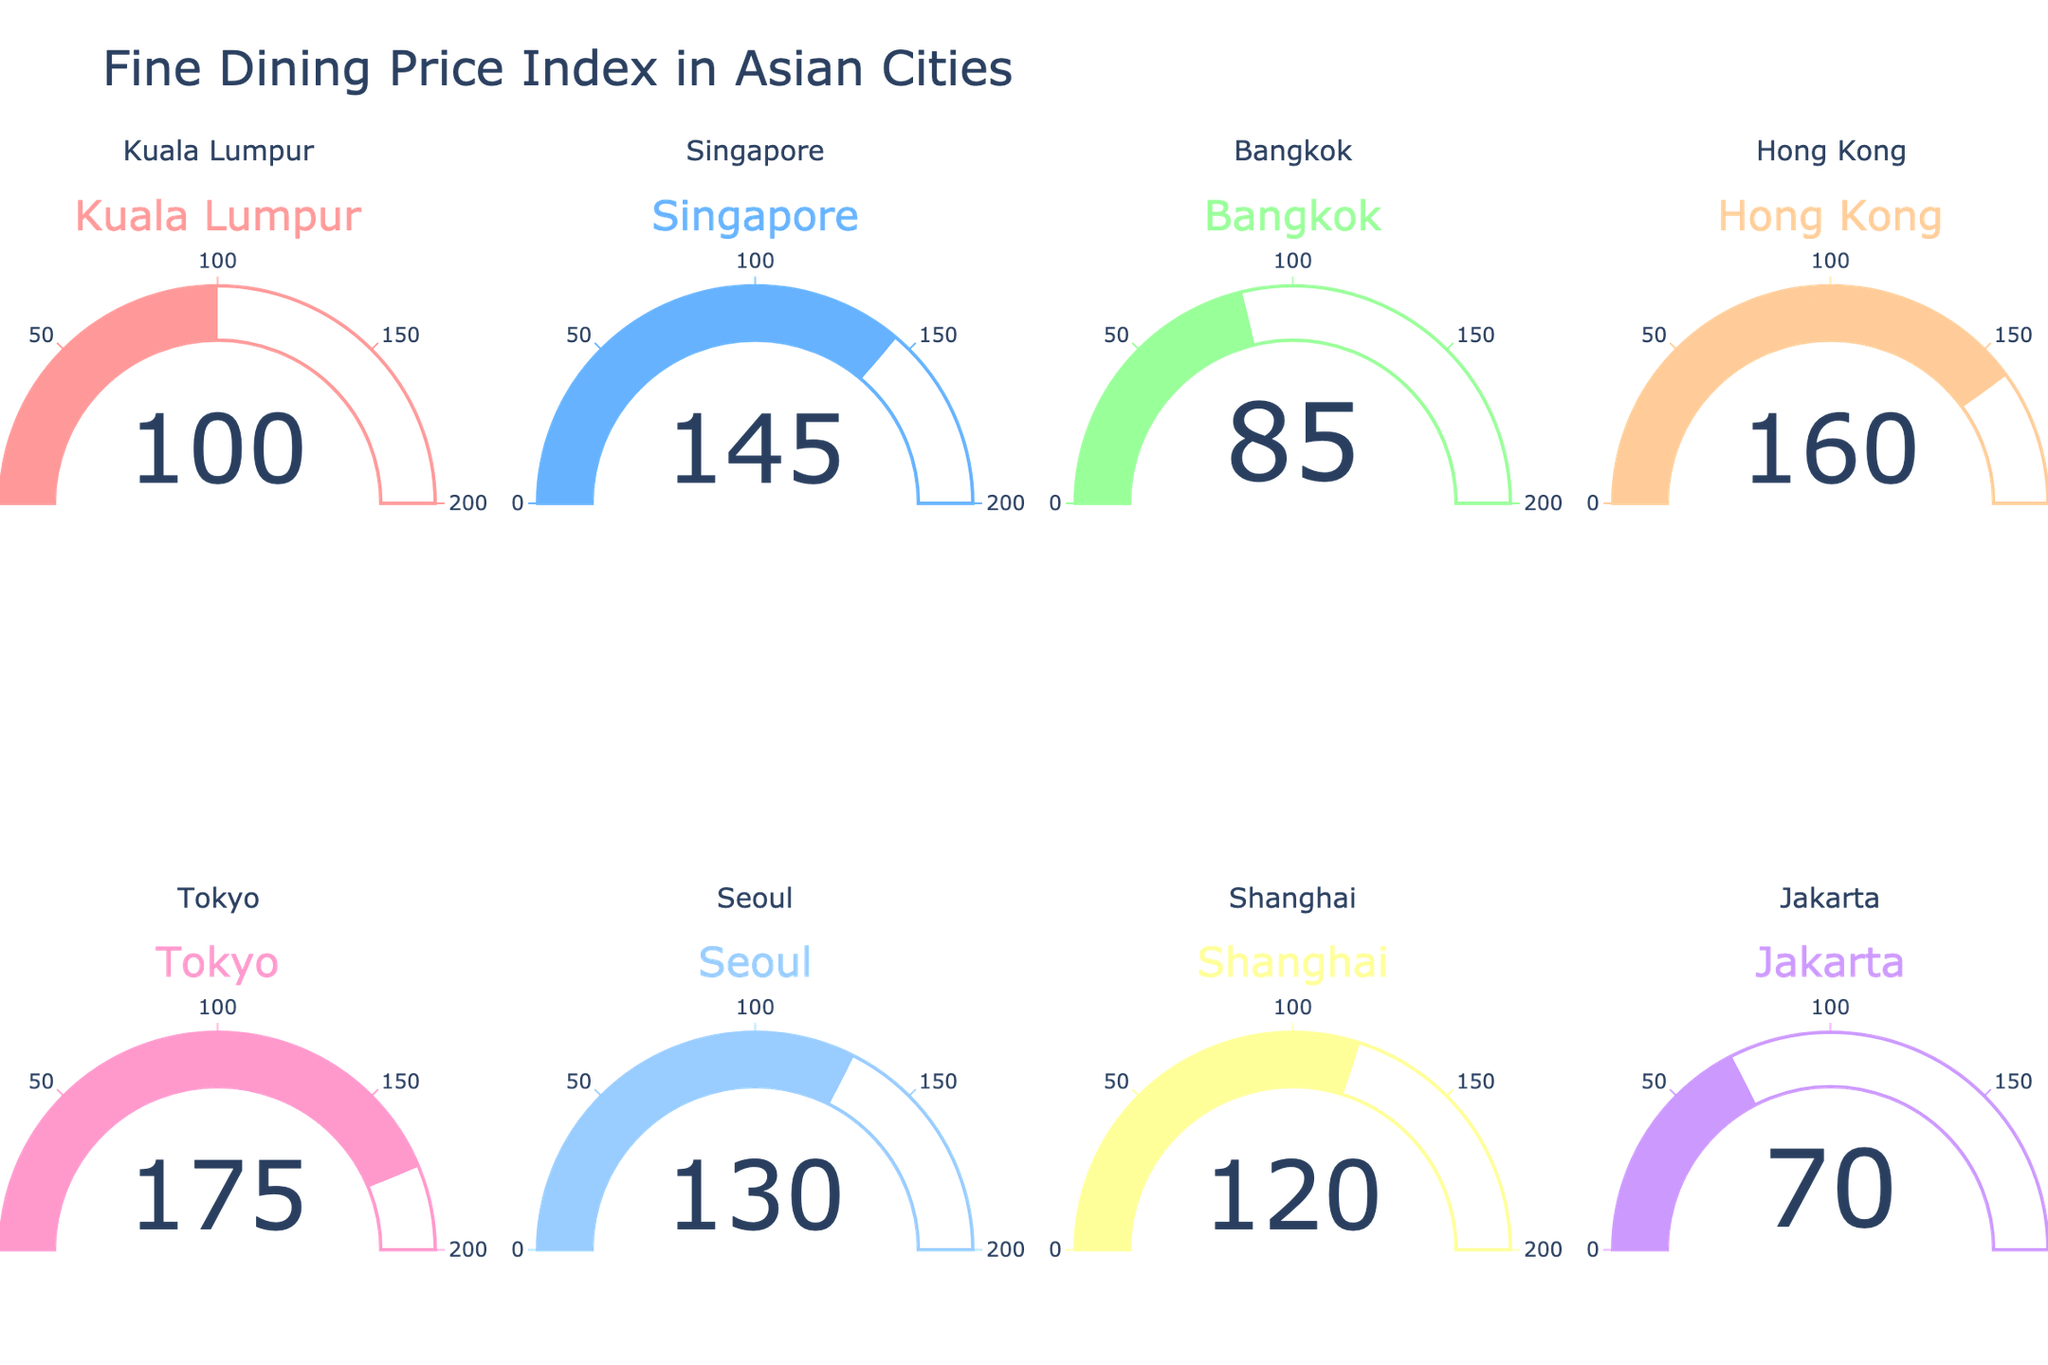What's the price index for Tokyo? The gauge chart indicates the price index for each city separately. For Tokyo, the gauge shows a value of 175.
Answer: 175 Which city has the highest price index? By examining each gauge, the highest numerical value is seen in Tokyo with a price index of 175.
Answer: Tokyo How does Kuala Lumpur's price index compare to Bangkok's? Kuala Lumpur has a price index of 100, and Bangkok has a price index of 85. Therefore, Kuala Lumpur's price index is higher than Bangkok's by 15 points.
Answer: Kuala Lumpur's is higher by 15 points What's the median price index of all the cities? Listing the price indices in ascending order: 70 (Jakarta), 85 (Bangkok), 100 (Kuala Lumpur), 120 (Shanghai), 130 (Seoul), 145 (Singapore), 160 (Hong Kong), 175 (Tokyo). The middle values (4th and 5th) are 120 and 130, so the median is (120 + 130) / 2 = 125.
Answer: 125 Which cities have a price index greater than 150? From the gauge chart, cities with a price index greater than 150 are Hong Kong (160) and Tokyo (175).
Answer: Hong Kong and Tokyo What's the price index difference between the city with the highest value and the city with the lowest value? The highest price index is 175 (Tokyo), and the lowest is 70 (Jakarta). The difference is 175 - 70 = 105.
Answer: 105 What is the average price index of all the cities shown? Sum of all price indices: 100 + 145 + 85 + 160 + 175 + 130 + 120 + 70 = 985. Number of cities is 8, so the average is 985 / 8 = 123.125.
Answer: 123.125 Looking at the color scheme, what color represents Kuala Lumpur, and how does it compare visually to the others? Kuala Lumpur is represented by a red shade, while other cities are shown in shades of blue, green, yellow, pink, and purple. This distinct red makes it easily identifiable compared to others.
Answer: Red, easily identifiable Which city has almost the same price index as Seoul but is slightly lower? Seoul has a price index of 130, and the closest but slightly lower value is Shanghai with 120.
Answer: Shanghai 